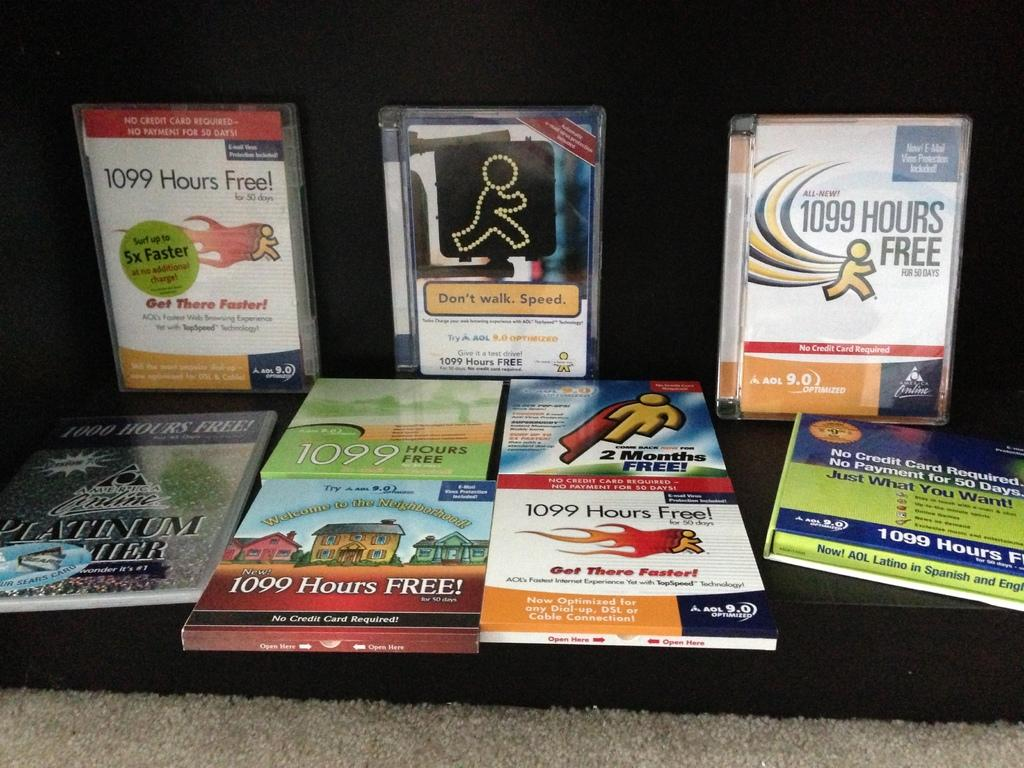<image>
Relay a brief, clear account of the picture shown. Several free offers from AOL such as 1099 hours free. 